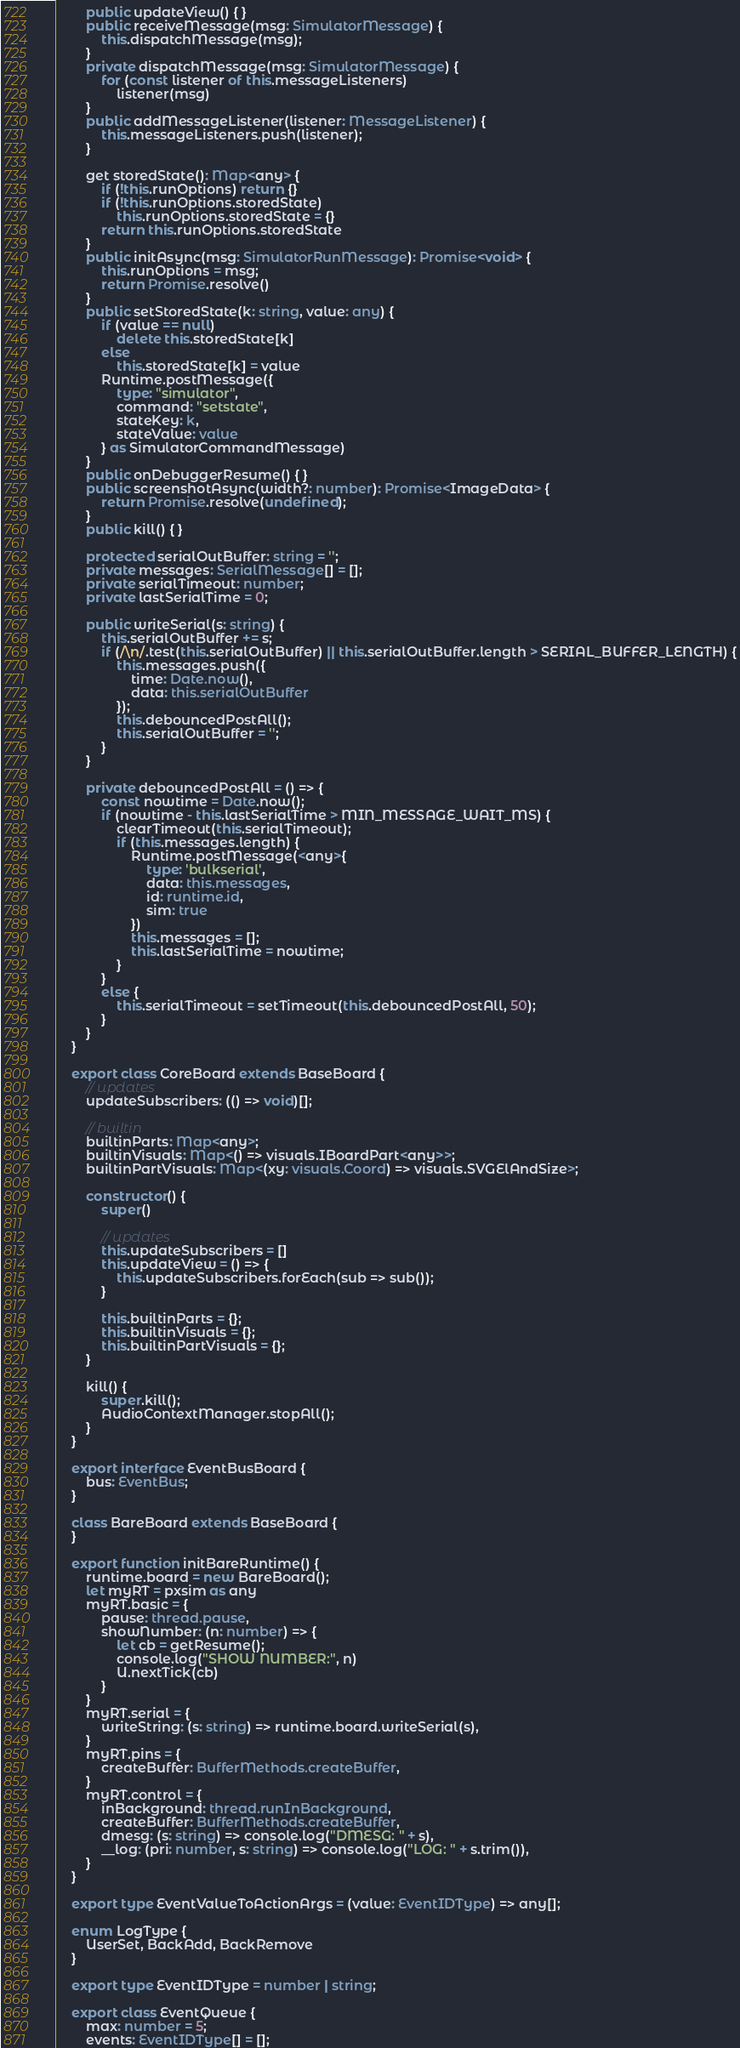<code> <loc_0><loc_0><loc_500><loc_500><_TypeScript_>        public updateView() { }
        public receiveMessage(msg: SimulatorMessage) {
            this.dispatchMessage(msg);
        }
        private dispatchMessage(msg: SimulatorMessage) {
            for (const listener of this.messageListeners)
                listener(msg)
        }
        public addMessageListener(listener: MessageListener) {
            this.messageListeners.push(listener);
        }

        get storedState(): Map<any> {
            if (!this.runOptions) return {}
            if (!this.runOptions.storedState)
                this.runOptions.storedState = {}
            return this.runOptions.storedState
        }
        public initAsync(msg: SimulatorRunMessage): Promise<void> {
            this.runOptions = msg;
            return Promise.resolve()
        }
        public setStoredState(k: string, value: any) {
            if (value == null)
                delete this.storedState[k]
            else
                this.storedState[k] = value
            Runtime.postMessage({
                type: "simulator",
                command: "setstate",
                stateKey: k,
                stateValue: value
            } as SimulatorCommandMessage)
        }
        public onDebuggerResume() { }
        public screenshotAsync(width?: number): Promise<ImageData> {
            return Promise.resolve(undefined);
        }
        public kill() { }

        protected serialOutBuffer: string = '';
        private messages: SerialMessage[] = [];
        private serialTimeout: number;
        private lastSerialTime = 0;

        public writeSerial(s: string) {
            this.serialOutBuffer += s;
            if (/\n/.test(this.serialOutBuffer) || this.serialOutBuffer.length > SERIAL_BUFFER_LENGTH) {
                this.messages.push({
                    time: Date.now(),
                    data: this.serialOutBuffer
                });
                this.debouncedPostAll();
                this.serialOutBuffer = '';
            }
        }

        private debouncedPostAll = () => {
            const nowtime = Date.now();
            if (nowtime - this.lastSerialTime > MIN_MESSAGE_WAIT_MS) {
                clearTimeout(this.serialTimeout);
                if (this.messages.length) {
                    Runtime.postMessage(<any>{
                        type: 'bulkserial',
                        data: this.messages,
                        id: runtime.id,
                        sim: true
                    })
                    this.messages = [];
                    this.lastSerialTime = nowtime;
                }
            }
            else {
                this.serialTimeout = setTimeout(this.debouncedPostAll, 50);
            }
        }
    }

    export class CoreBoard extends BaseBoard {
        // updates
        updateSubscribers: (() => void)[];

        // builtin
        builtinParts: Map<any>;
        builtinVisuals: Map<() => visuals.IBoardPart<any>>;
        builtinPartVisuals: Map<(xy: visuals.Coord) => visuals.SVGElAndSize>;

        constructor() {
            super()

            // updates
            this.updateSubscribers = []
            this.updateView = () => {
                this.updateSubscribers.forEach(sub => sub());
            }

            this.builtinParts = {};
            this.builtinVisuals = {};
            this.builtinPartVisuals = {};
        }

        kill() {
            super.kill();
            AudioContextManager.stopAll();
        }
    }

    export interface EventBusBoard {
        bus: EventBus;
    }

    class BareBoard extends BaseBoard {
    }

    export function initBareRuntime() {
        runtime.board = new BareBoard();
        let myRT = pxsim as any
        myRT.basic = {
            pause: thread.pause,
            showNumber: (n: number) => {
                let cb = getResume();
                console.log("SHOW NUMBER:", n)
                U.nextTick(cb)
            }
        }
        myRT.serial = {
            writeString: (s: string) => runtime.board.writeSerial(s),
        }
        myRT.pins = {
            createBuffer: BufferMethods.createBuffer,
        }
        myRT.control = {
            inBackground: thread.runInBackground,
            createBuffer: BufferMethods.createBuffer,
            dmesg: (s: string) => console.log("DMESG: " + s),
            __log: (pri: number, s: string) => console.log("LOG: " + s.trim()),
        }
    }

    export type EventValueToActionArgs = (value: EventIDType) => any[];

    enum LogType {
        UserSet, BackAdd, BackRemove
    }

    export type EventIDType = number | string;

    export class EventQueue {
        max: number = 5;
        events: EventIDType[] = [];</code> 